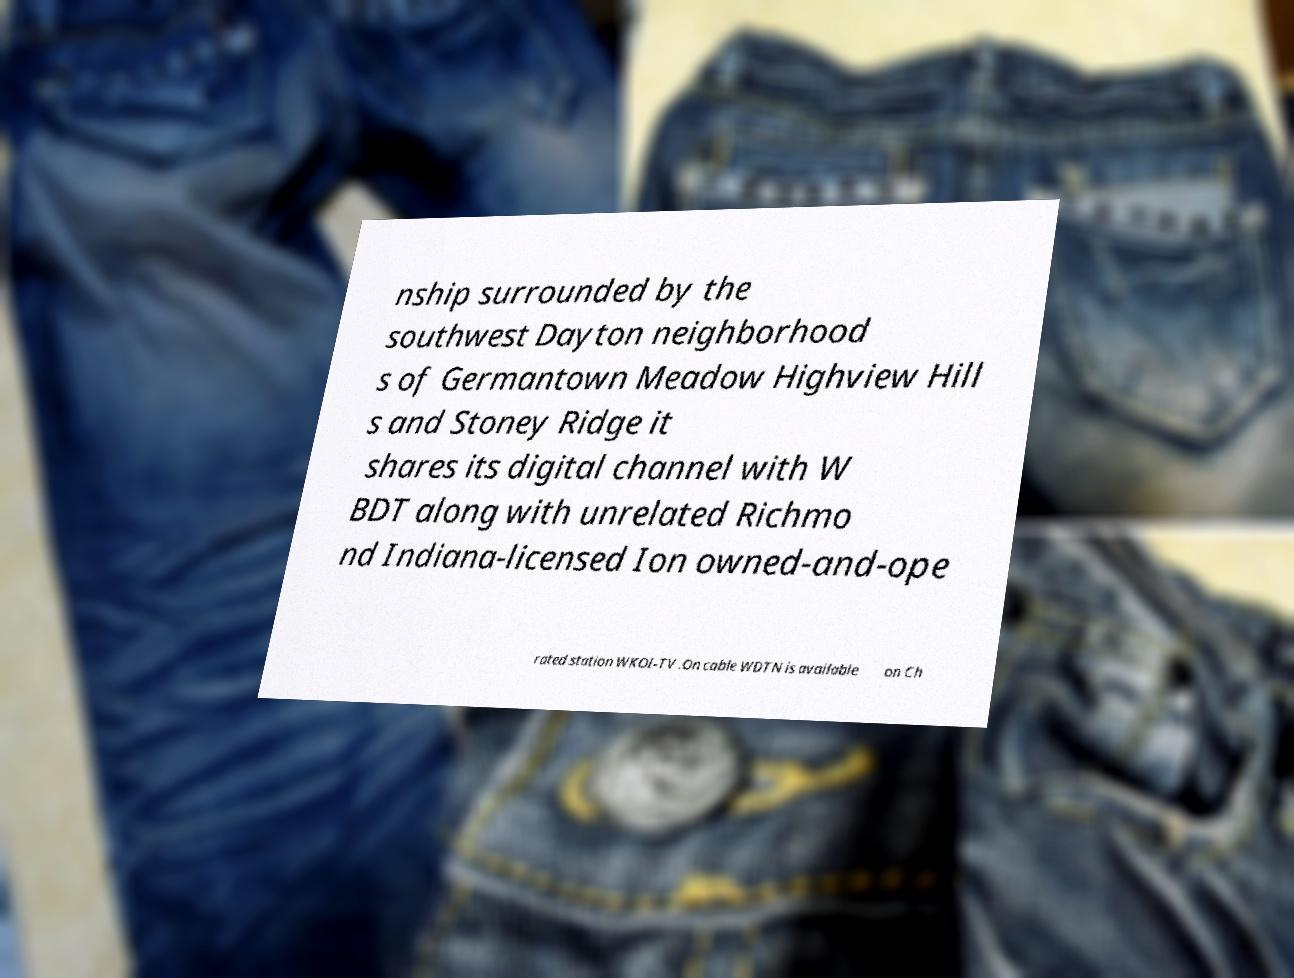Could you extract and type out the text from this image? nship surrounded by the southwest Dayton neighborhood s of Germantown Meadow Highview Hill s and Stoney Ridge it shares its digital channel with W BDT along with unrelated Richmo nd Indiana-licensed Ion owned-and-ope rated station WKOI-TV .On cable WDTN is available on Ch 